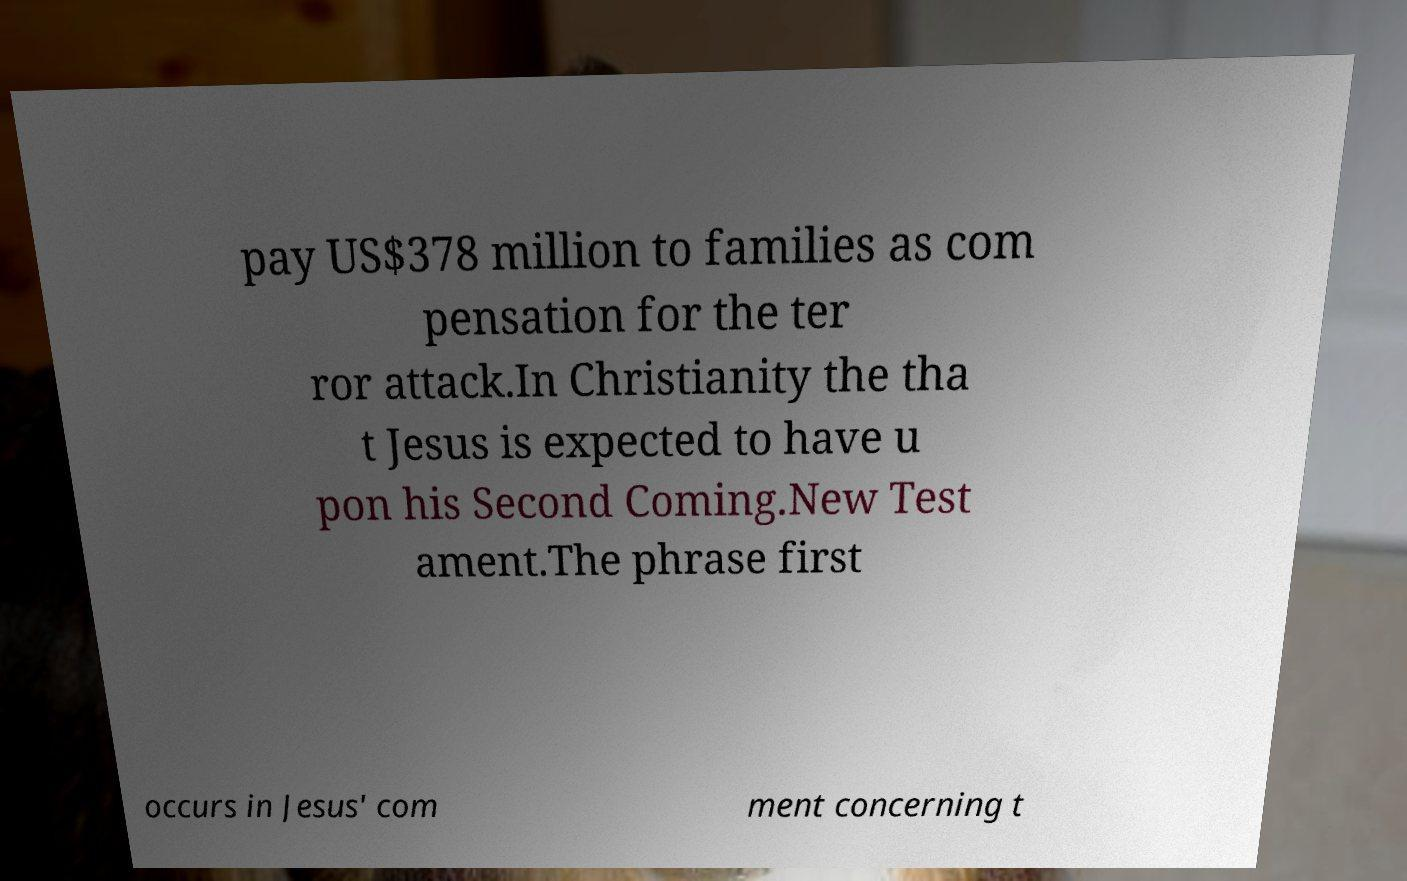I need the written content from this picture converted into text. Can you do that? pay US$378 million to families as com pensation for the ter ror attack.In Christianity the tha t Jesus is expected to have u pon his Second Coming.New Test ament.The phrase first occurs in Jesus' com ment concerning t 